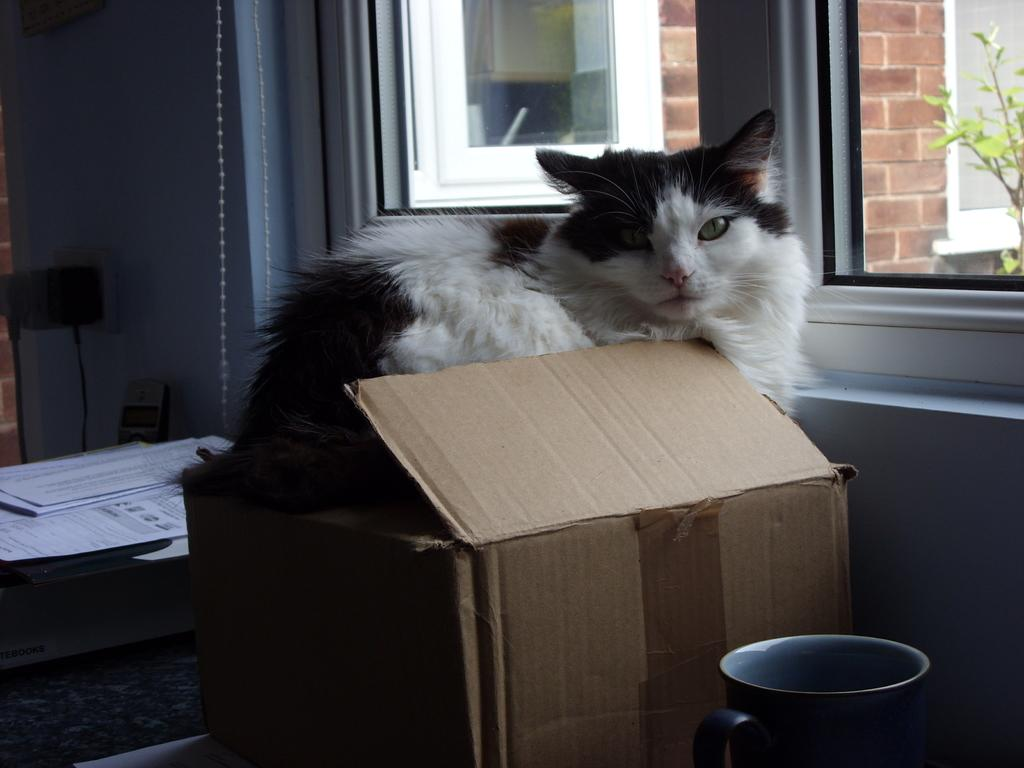What type of object is depicted in the image? There is a cartoon box in the image. What other items can be seen in the image? There is a mug, windows, a plant, papers, and a cat in the image. What is written on the papers? Something is written on the papers, but the specific content is not mentioned in the facts. What color is the cat in the image? The cat's color is black and white. What flavor of card can be seen in the image? There is no card present in the image, and therefore no flavor can be associated with it. Is there a cactus visible in the image? No, there is no cactus present in the image. 